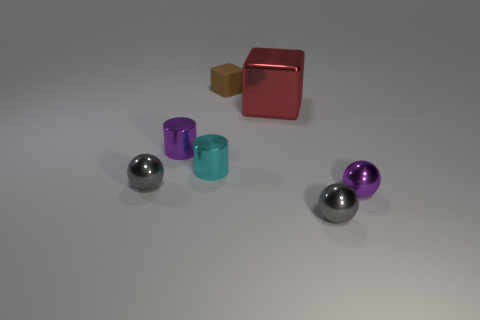Does the sphere to the left of the brown matte block have the same material as the tiny cyan thing?
Keep it short and to the point. Yes. There is a small purple object on the right side of the small shiny cylinder to the right of the tiny purple metallic cylinder; is there a gray sphere that is in front of it?
Provide a short and direct response. Yes. Is the shape of the tiny purple metallic object that is right of the matte cube the same as  the cyan shiny thing?
Keep it short and to the point. No. The small purple shiny object left of the tiny brown object behind the cyan object is what shape?
Make the answer very short. Cylinder. There is a gray shiny sphere to the left of the gray thing that is in front of the gray metal ball behind the purple sphere; how big is it?
Provide a succinct answer. Small. There is a rubber object that is the same shape as the red shiny thing; what color is it?
Your answer should be very brief. Brown. Do the purple shiny ball and the red metallic object have the same size?
Keep it short and to the point. No. What is the gray thing that is on the right side of the cyan cylinder made of?
Provide a succinct answer. Metal. How many other things are the same shape as the red object?
Your response must be concise. 1. Is the big metallic object the same shape as the cyan thing?
Provide a succinct answer. No. 